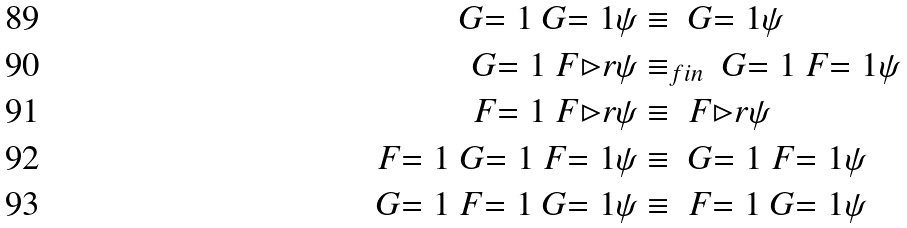Convert formula to latex. <formula><loc_0><loc_0><loc_500><loc_500>\ G { = 1 } \ G { = 1 } \psi & \equiv \ G { = 1 } \psi \\ \ G { = 1 } { \ F { \rhd r } { \psi } } & \equiv _ { f i n } \ G { = 1 } { \ F { = 1 } { \psi } } \\ \ F { = 1 } { \ F { \rhd r } { \psi } } & \equiv \ F { \rhd r } { \psi } \\ \ F { = 1 } { \ G { = 1 } { \ F { = 1 } { \psi } } } & \equiv \ G { = 1 } { \ F { = 1 } { \psi } } \\ \ G { = 1 } { \ F { = 1 } { \ G { = 1 } { \psi } } } & \equiv \ F { = 1 } { \ G { = 1 } { \psi } }</formula> 